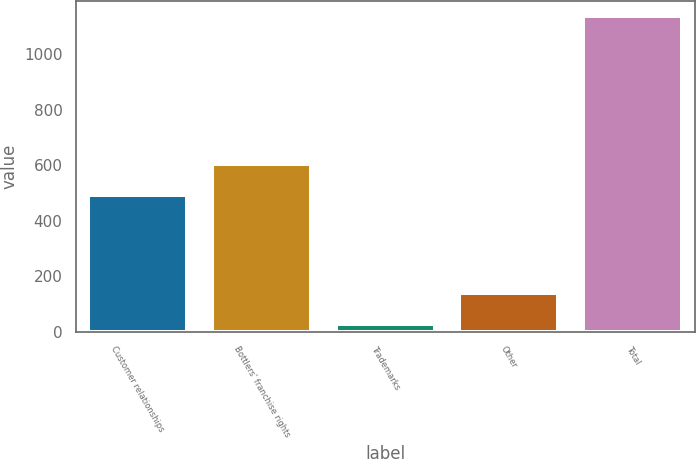Convert chart to OTSL. <chart><loc_0><loc_0><loc_500><loc_500><bar_chart><fcel>Customer relationships<fcel>Bottlers' franchise rights<fcel>Trademarks<fcel>Other<fcel>Total<nl><fcel>493<fcel>603.8<fcel>29<fcel>139.8<fcel>1137<nl></chart> 